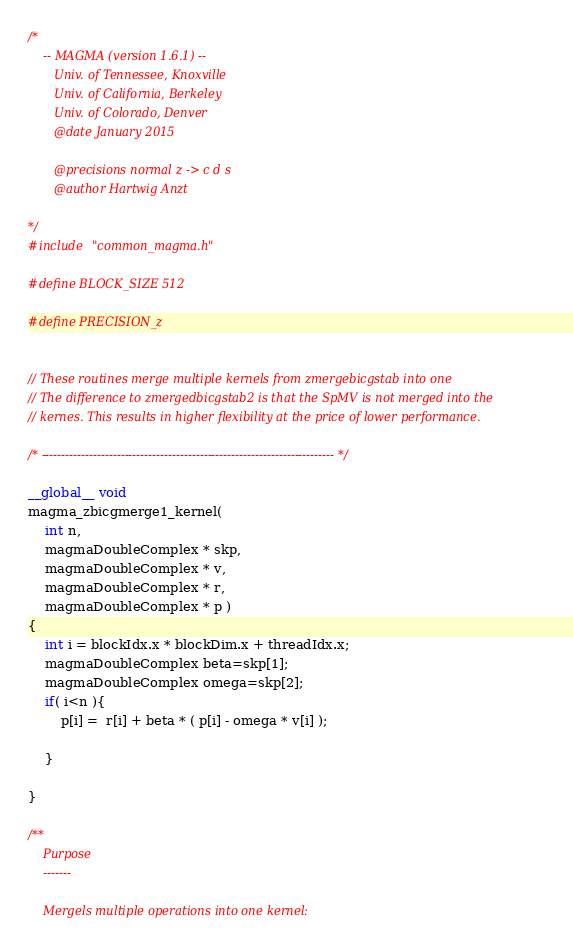<code> <loc_0><loc_0><loc_500><loc_500><_Cuda_>/*
    -- MAGMA (version 1.6.1) --
       Univ. of Tennessee, Knoxville
       Univ. of California, Berkeley
       Univ. of Colorado, Denver
       @date January 2015

       @precisions normal z -> c d s
       @author Hartwig Anzt

*/
#include "common_magma.h"

#define BLOCK_SIZE 512

#define PRECISION_z


// These routines merge multiple kernels from zmergebicgstab into one
// The difference to zmergedbicgstab2 is that the SpMV is not merged into the
// kernes. This results in higher flexibility at the price of lower performance.

/* -------------------------------------------------------------------------- */

__global__ void
magma_zbicgmerge1_kernel(  
    int n, 
    magmaDoubleComplex * skp,
    magmaDoubleComplex * v, 
    magmaDoubleComplex * r, 
    magmaDoubleComplex * p )
{
    int i = blockIdx.x * blockDim.x + threadIdx.x;
    magmaDoubleComplex beta=skp[1];
    magmaDoubleComplex omega=skp[2];
    if( i<n ){
        p[i] =  r[i] + beta * ( p[i] - omega * v[i] );

    }

}

/**
    Purpose
    -------

    Mergels multiple operations into one kernel:
</code> 